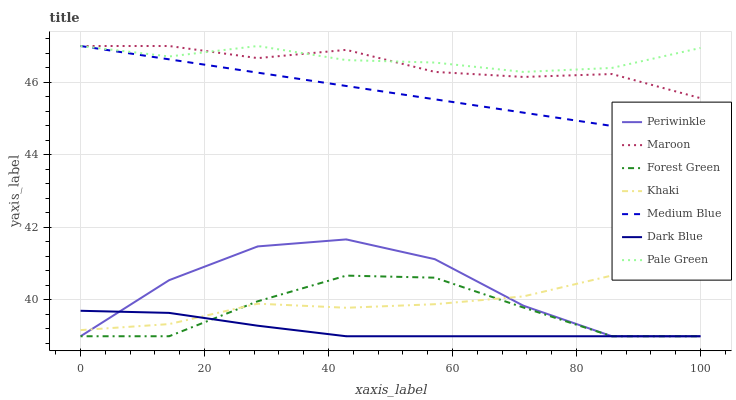Does Dark Blue have the minimum area under the curve?
Answer yes or no. Yes. Does Pale Green have the maximum area under the curve?
Answer yes or no. Yes. Does Medium Blue have the minimum area under the curve?
Answer yes or no. No. Does Medium Blue have the maximum area under the curve?
Answer yes or no. No. Is Medium Blue the smoothest?
Answer yes or no. Yes. Is Periwinkle the roughest?
Answer yes or no. Yes. Is Maroon the smoothest?
Answer yes or no. No. Is Maroon the roughest?
Answer yes or no. No. Does Dark Blue have the lowest value?
Answer yes or no. Yes. Does Medium Blue have the lowest value?
Answer yes or no. No. Does Pale Green have the highest value?
Answer yes or no. Yes. Does Dark Blue have the highest value?
Answer yes or no. No. Is Periwinkle less than Maroon?
Answer yes or no. Yes. Is Pale Green greater than Forest Green?
Answer yes or no. Yes. Does Medium Blue intersect Pale Green?
Answer yes or no. Yes. Is Medium Blue less than Pale Green?
Answer yes or no. No. Is Medium Blue greater than Pale Green?
Answer yes or no. No. Does Periwinkle intersect Maroon?
Answer yes or no. No. 